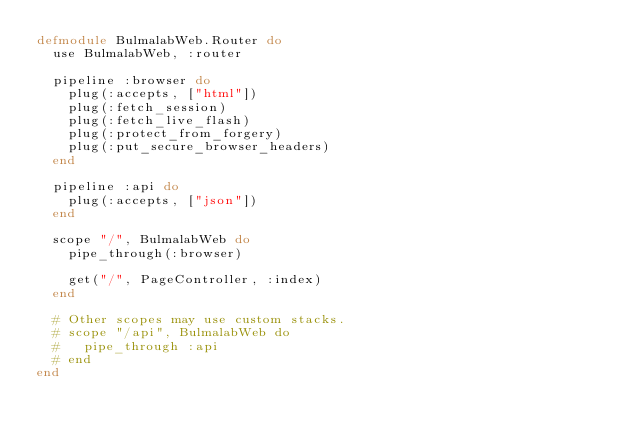Convert code to text. <code><loc_0><loc_0><loc_500><loc_500><_Elixir_>defmodule BulmalabWeb.Router do
  use BulmalabWeb, :router

  pipeline :browser do
    plug(:accepts, ["html"])
    plug(:fetch_session)
    plug(:fetch_live_flash)
    plug(:protect_from_forgery)
    plug(:put_secure_browser_headers)
  end

  pipeline :api do
    plug(:accepts, ["json"])
  end

  scope "/", BulmalabWeb do
    pipe_through(:browser)

    get("/", PageController, :index)
  end

  # Other scopes may use custom stacks.
  # scope "/api", BulmalabWeb do
  #   pipe_through :api
  # end
end
</code> 